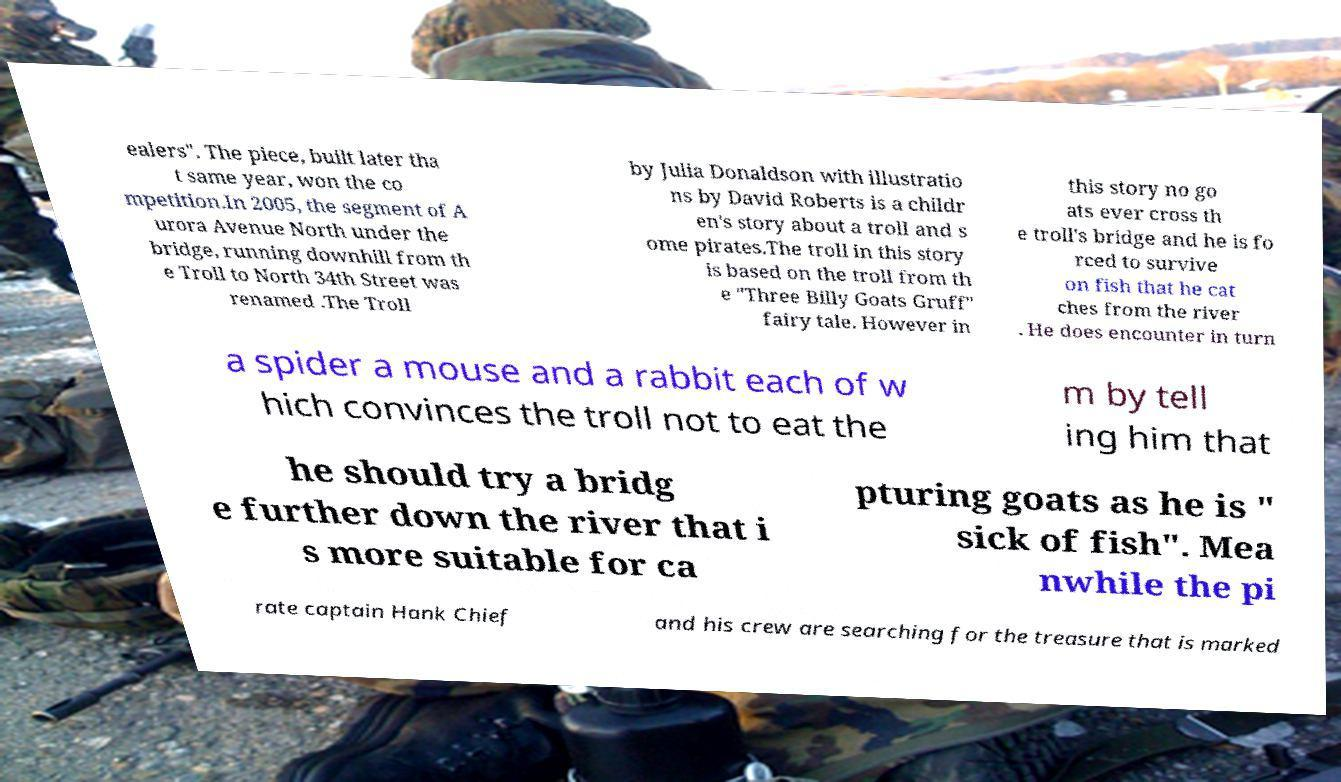What messages or text are displayed in this image? I need them in a readable, typed format. ealers". The piece, built later tha t same year, won the co mpetition.In 2005, the segment of A urora Avenue North under the bridge, running downhill from th e Troll to North 34th Street was renamed .The Troll by Julia Donaldson with illustratio ns by David Roberts is a childr en's story about a troll and s ome pirates.The troll in this story is based on the troll from th e "Three Billy Goats Gruff" fairy tale. However in this story no go ats ever cross th e troll's bridge and he is fo rced to survive on fish that he cat ches from the river . He does encounter in turn a spider a mouse and a rabbit each of w hich convinces the troll not to eat the m by tell ing him that he should try a bridg e further down the river that i s more suitable for ca pturing goats as he is " sick of fish". Mea nwhile the pi rate captain Hank Chief and his crew are searching for the treasure that is marked 